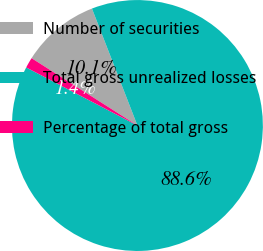Convert chart to OTSL. <chart><loc_0><loc_0><loc_500><loc_500><pie_chart><fcel>Number of securities<fcel>Total gross unrealized losses<fcel>Percentage of total gross<nl><fcel>10.08%<fcel>88.55%<fcel>1.36%<nl></chart> 